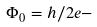Convert formula to latex. <formula><loc_0><loc_0><loc_500><loc_500>\Phi _ { 0 } = h / 2 e -</formula> 